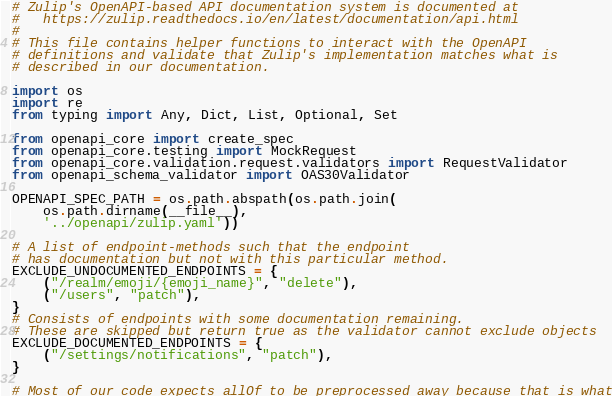Convert code to text. <code><loc_0><loc_0><loc_500><loc_500><_Python_># Zulip's OpenAPI-based API documentation system is documented at
#   https://zulip.readthedocs.io/en/latest/documentation/api.html
#
# This file contains helper functions to interact with the OpenAPI
# definitions and validate that Zulip's implementation matches what is
# described in our documentation.

import os
import re
from typing import Any, Dict, List, Optional, Set

from openapi_core import create_spec
from openapi_core.testing import MockRequest
from openapi_core.validation.request.validators import RequestValidator
from openapi_schema_validator import OAS30Validator

OPENAPI_SPEC_PATH = os.path.abspath(os.path.join(
    os.path.dirname(__file__),
    '../openapi/zulip.yaml'))

# A list of endpoint-methods such that the endpoint
# has documentation but not with this particular method.
EXCLUDE_UNDOCUMENTED_ENDPOINTS = {
    ("/realm/emoji/{emoji_name}", "delete"),
    ("/users", "patch"),
}
# Consists of endpoints with some documentation remaining.
# These are skipped but return true as the validator cannot exclude objects
EXCLUDE_DOCUMENTED_ENDPOINTS = {
    ("/settings/notifications", "patch"),
}

# Most of our code expects allOf to be preprocessed away because that is what</code> 